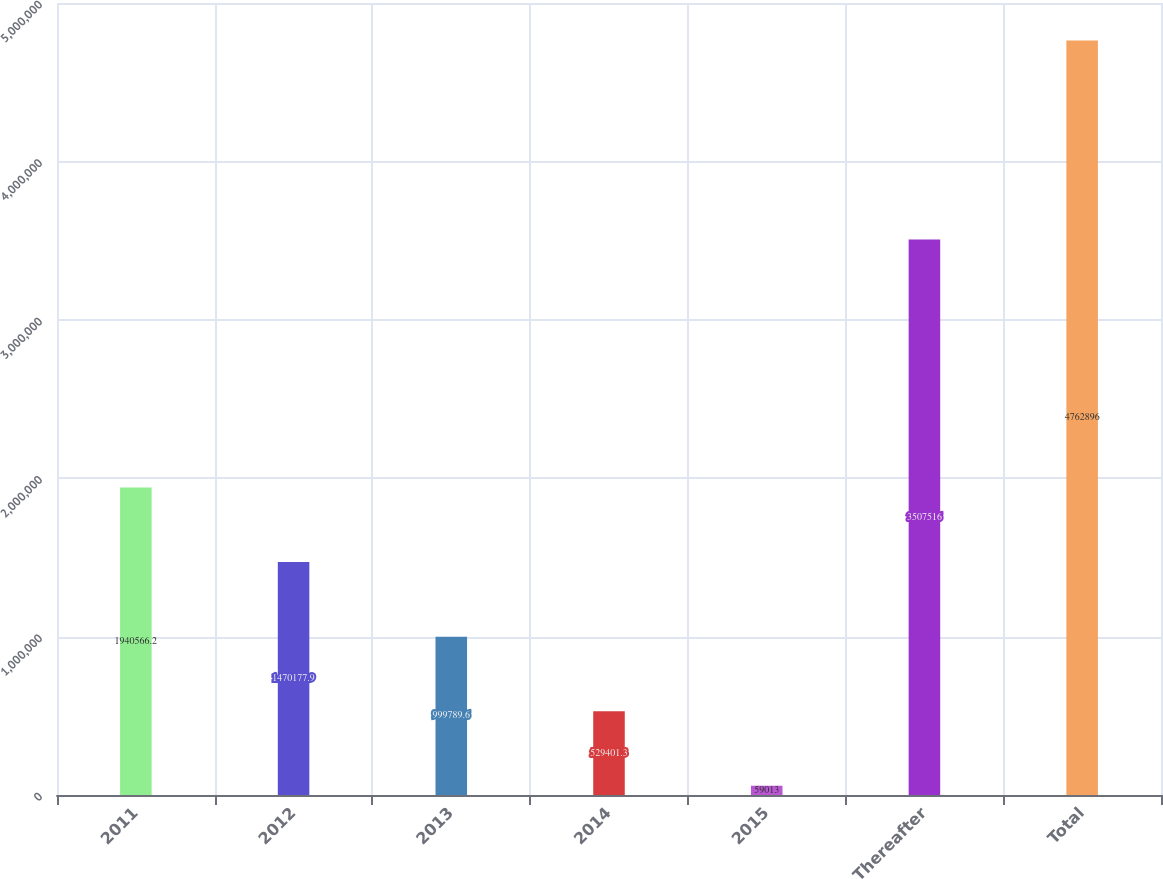<chart> <loc_0><loc_0><loc_500><loc_500><bar_chart><fcel>2011<fcel>2012<fcel>2013<fcel>2014<fcel>2015<fcel>Thereafter<fcel>Total<nl><fcel>1.94057e+06<fcel>1.47018e+06<fcel>999790<fcel>529401<fcel>59013<fcel>3.50752e+06<fcel>4.7629e+06<nl></chart> 